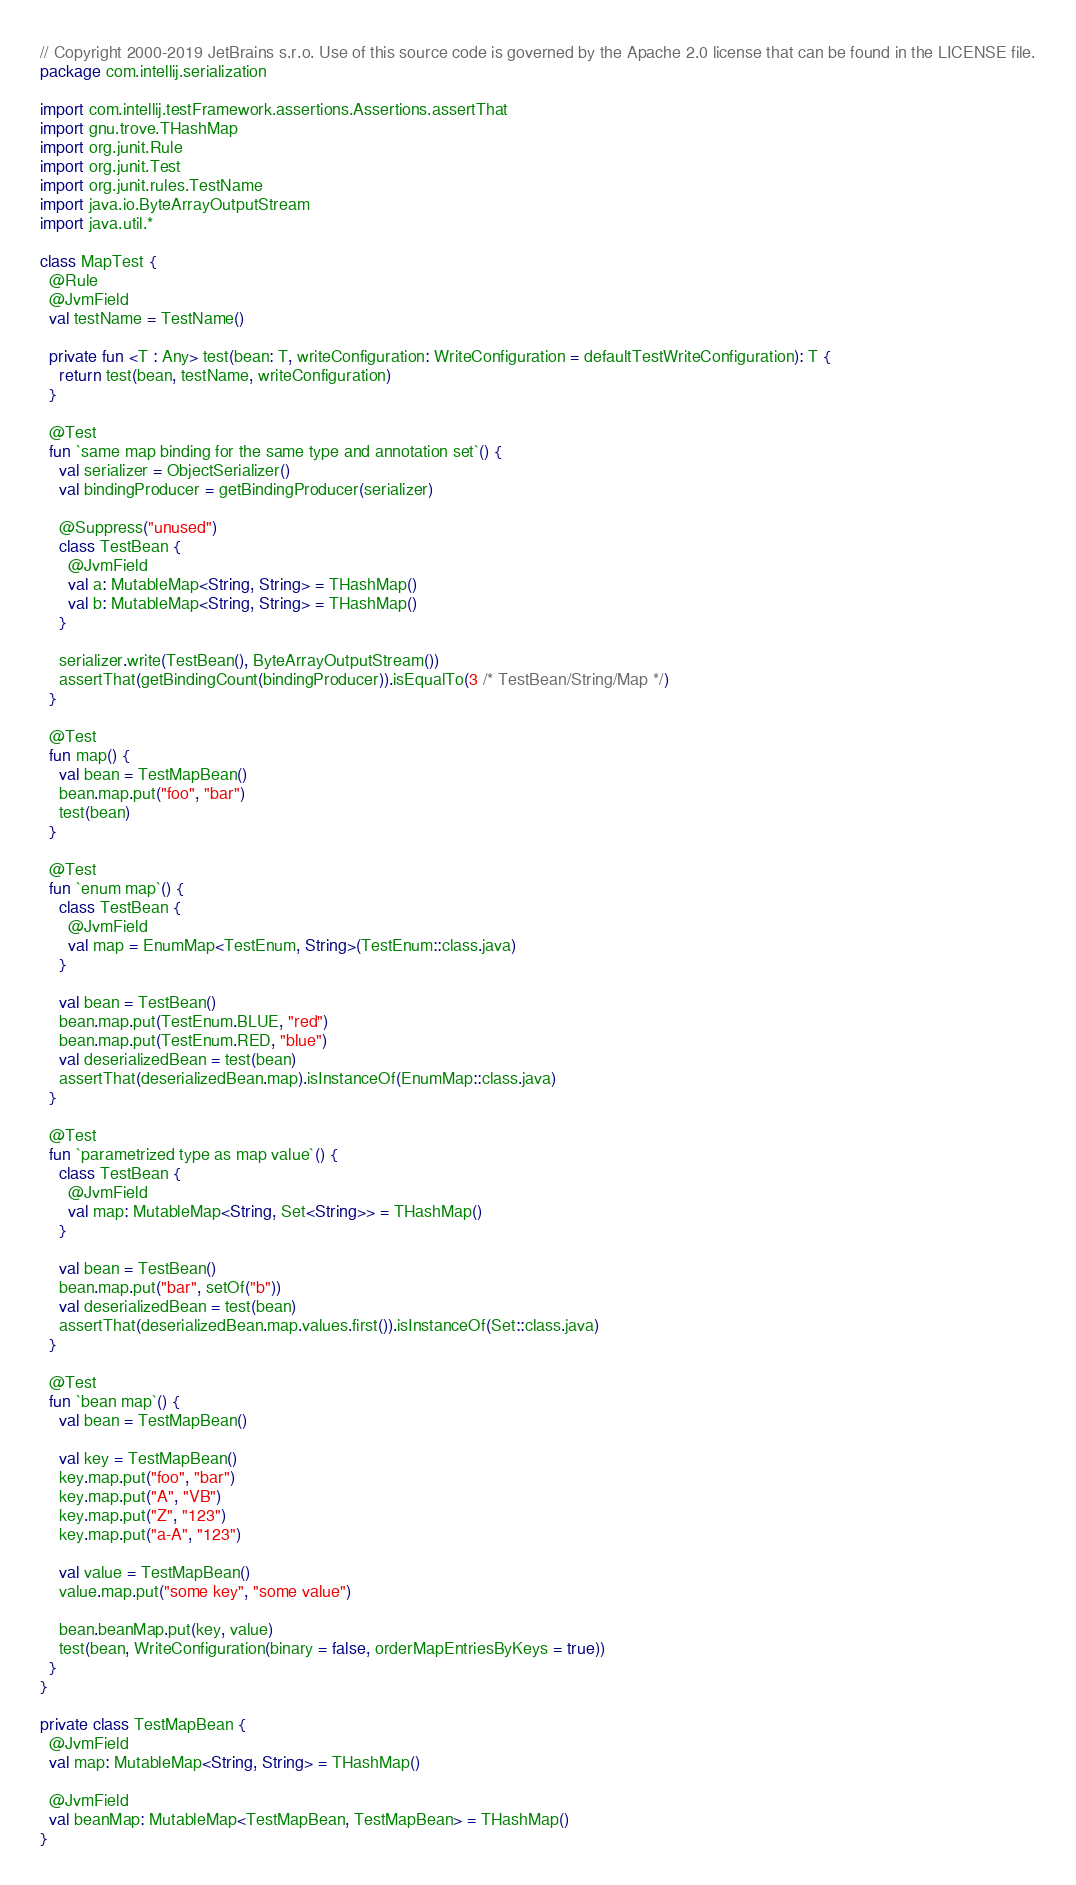Convert code to text. <code><loc_0><loc_0><loc_500><loc_500><_Kotlin_>// Copyright 2000-2019 JetBrains s.r.o. Use of this source code is governed by the Apache 2.0 license that can be found in the LICENSE file.
package com.intellij.serialization

import com.intellij.testFramework.assertions.Assertions.assertThat
import gnu.trove.THashMap
import org.junit.Rule
import org.junit.Test
import org.junit.rules.TestName
import java.io.ByteArrayOutputStream
import java.util.*

class MapTest {
  @Rule
  @JvmField
  val testName = TestName()

  private fun <T : Any> test(bean: T, writeConfiguration: WriteConfiguration = defaultTestWriteConfiguration): T {
    return test(bean, testName, writeConfiguration)
  }

  @Test
  fun `same map binding for the same type and annotation set`() {
    val serializer = ObjectSerializer()
    val bindingProducer = getBindingProducer(serializer)

    @Suppress("unused")
    class TestBean {
      @JvmField
      val a: MutableMap<String, String> = THashMap()
      val b: MutableMap<String, String> = THashMap()
    }

    serializer.write(TestBean(), ByteArrayOutputStream())
    assertThat(getBindingCount(bindingProducer)).isEqualTo(3 /* TestBean/String/Map */)
  }

  @Test
  fun map() {
    val bean = TestMapBean()
    bean.map.put("foo", "bar")
    test(bean)
  }

  @Test
  fun `enum map`() {
    class TestBean {
      @JvmField
      val map = EnumMap<TestEnum, String>(TestEnum::class.java)
    }

    val bean = TestBean()
    bean.map.put(TestEnum.BLUE, "red")
    bean.map.put(TestEnum.RED, "blue")
    val deserializedBean = test(bean)
    assertThat(deserializedBean.map).isInstanceOf(EnumMap::class.java)
  }

  @Test
  fun `parametrized type as map value`() {
    class TestBean {
      @JvmField
      val map: MutableMap<String, Set<String>> = THashMap()
    }

    val bean = TestBean()
    bean.map.put("bar", setOf("b"))
    val deserializedBean = test(bean)
    assertThat(deserializedBean.map.values.first()).isInstanceOf(Set::class.java)
  }

  @Test
  fun `bean map`() {
    val bean = TestMapBean()

    val key = TestMapBean()
    key.map.put("foo", "bar")
    key.map.put("A", "VB")
    key.map.put("Z", "123")
    key.map.put("a-A", "123")

    val value = TestMapBean()
    value.map.put("some key", "some value")

    bean.beanMap.put(key, value)
    test(bean, WriteConfiguration(binary = false, orderMapEntriesByKeys = true))
  }
}

private class TestMapBean {
  @JvmField
  val map: MutableMap<String, String> = THashMap()

  @JvmField
  val beanMap: MutableMap<TestMapBean, TestMapBean> = THashMap()
}
</code> 